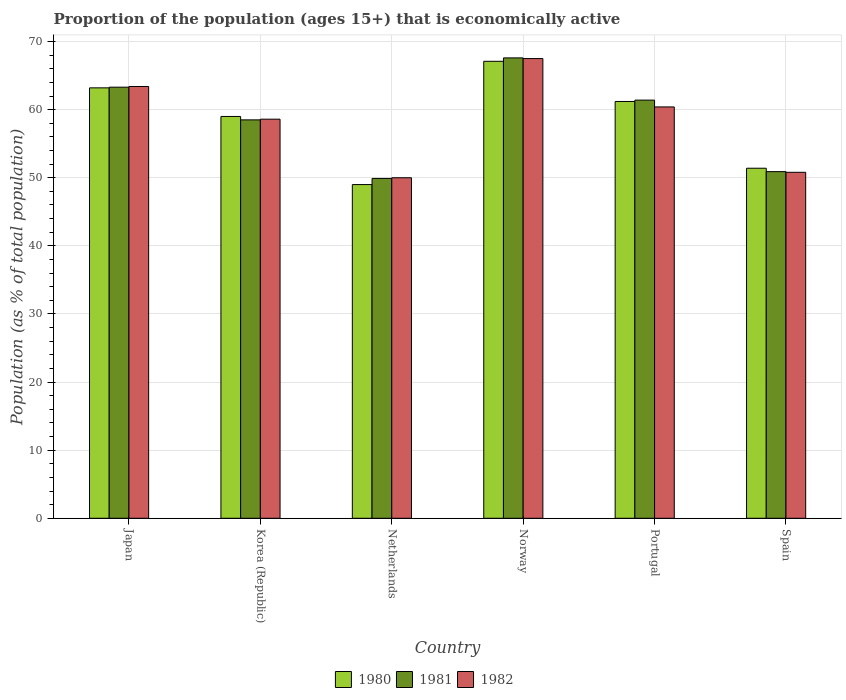How many groups of bars are there?
Your response must be concise. 6. Are the number of bars per tick equal to the number of legend labels?
Keep it short and to the point. Yes. Are the number of bars on each tick of the X-axis equal?
Keep it short and to the point. Yes. How many bars are there on the 5th tick from the right?
Provide a succinct answer. 3. What is the label of the 2nd group of bars from the left?
Your answer should be compact. Korea (Republic). In how many cases, is the number of bars for a given country not equal to the number of legend labels?
Make the answer very short. 0. What is the proportion of the population that is economically active in 1980 in Korea (Republic)?
Your answer should be compact. 59. Across all countries, what is the maximum proportion of the population that is economically active in 1981?
Make the answer very short. 67.6. In which country was the proportion of the population that is economically active in 1980 minimum?
Your response must be concise. Netherlands. What is the total proportion of the population that is economically active in 1982 in the graph?
Give a very brief answer. 350.7. What is the difference between the proportion of the population that is economically active in 1980 in Japan and that in Netherlands?
Give a very brief answer. 14.2. What is the difference between the proportion of the population that is economically active in 1981 in Norway and the proportion of the population that is economically active in 1980 in Korea (Republic)?
Your answer should be compact. 8.6. What is the average proportion of the population that is economically active in 1981 per country?
Your answer should be very brief. 58.6. What is the difference between the proportion of the population that is economically active of/in 1982 and proportion of the population that is economically active of/in 1980 in Korea (Republic)?
Give a very brief answer. -0.4. In how many countries, is the proportion of the population that is economically active in 1980 greater than 4 %?
Offer a terse response. 6. What is the ratio of the proportion of the population that is economically active in 1980 in Netherlands to that in Norway?
Provide a succinct answer. 0.73. Is the difference between the proportion of the population that is economically active in 1982 in Japan and Portugal greater than the difference between the proportion of the population that is economically active in 1980 in Japan and Portugal?
Offer a very short reply. Yes. What is the difference between the highest and the second highest proportion of the population that is economically active in 1981?
Offer a very short reply. 6.2. What is the difference between the highest and the lowest proportion of the population that is economically active in 1982?
Your answer should be very brief. 17.5. In how many countries, is the proportion of the population that is economically active in 1980 greater than the average proportion of the population that is economically active in 1980 taken over all countries?
Make the answer very short. 4. Is the sum of the proportion of the population that is economically active in 1982 in Korea (Republic) and Spain greater than the maximum proportion of the population that is economically active in 1981 across all countries?
Your answer should be very brief. Yes. What does the 1st bar from the left in Netherlands represents?
Your answer should be very brief. 1980. What does the 1st bar from the right in Japan represents?
Make the answer very short. 1982. Are all the bars in the graph horizontal?
Offer a terse response. No. How many countries are there in the graph?
Your response must be concise. 6. What is the difference between two consecutive major ticks on the Y-axis?
Provide a short and direct response. 10. Does the graph contain grids?
Provide a succinct answer. Yes. What is the title of the graph?
Offer a very short reply. Proportion of the population (ages 15+) that is economically active. What is the label or title of the X-axis?
Offer a terse response. Country. What is the label or title of the Y-axis?
Offer a very short reply. Population (as % of total population). What is the Population (as % of total population) in 1980 in Japan?
Provide a short and direct response. 63.2. What is the Population (as % of total population) in 1981 in Japan?
Your response must be concise. 63.3. What is the Population (as % of total population) in 1982 in Japan?
Make the answer very short. 63.4. What is the Population (as % of total population) in 1980 in Korea (Republic)?
Your answer should be very brief. 59. What is the Population (as % of total population) of 1981 in Korea (Republic)?
Offer a very short reply. 58.5. What is the Population (as % of total population) in 1982 in Korea (Republic)?
Keep it short and to the point. 58.6. What is the Population (as % of total population) in 1980 in Netherlands?
Keep it short and to the point. 49. What is the Population (as % of total population) in 1981 in Netherlands?
Your answer should be compact. 49.9. What is the Population (as % of total population) in 1980 in Norway?
Offer a very short reply. 67.1. What is the Population (as % of total population) of 1981 in Norway?
Provide a short and direct response. 67.6. What is the Population (as % of total population) of 1982 in Norway?
Make the answer very short. 67.5. What is the Population (as % of total population) in 1980 in Portugal?
Your response must be concise. 61.2. What is the Population (as % of total population) of 1981 in Portugal?
Make the answer very short. 61.4. What is the Population (as % of total population) of 1982 in Portugal?
Ensure brevity in your answer.  60.4. What is the Population (as % of total population) of 1980 in Spain?
Provide a succinct answer. 51.4. What is the Population (as % of total population) of 1981 in Spain?
Give a very brief answer. 50.9. What is the Population (as % of total population) in 1982 in Spain?
Offer a very short reply. 50.8. Across all countries, what is the maximum Population (as % of total population) of 1980?
Give a very brief answer. 67.1. Across all countries, what is the maximum Population (as % of total population) of 1981?
Offer a very short reply. 67.6. Across all countries, what is the maximum Population (as % of total population) in 1982?
Your answer should be compact. 67.5. Across all countries, what is the minimum Population (as % of total population) in 1980?
Make the answer very short. 49. Across all countries, what is the minimum Population (as % of total population) in 1981?
Offer a very short reply. 49.9. Across all countries, what is the minimum Population (as % of total population) of 1982?
Provide a short and direct response. 50. What is the total Population (as % of total population) of 1980 in the graph?
Your response must be concise. 350.9. What is the total Population (as % of total population) of 1981 in the graph?
Keep it short and to the point. 351.6. What is the total Population (as % of total population) in 1982 in the graph?
Your answer should be very brief. 350.7. What is the difference between the Population (as % of total population) in 1980 in Japan and that in Korea (Republic)?
Offer a very short reply. 4.2. What is the difference between the Population (as % of total population) of 1982 in Japan and that in Korea (Republic)?
Ensure brevity in your answer.  4.8. What is the difference between the Population (as % of total population) of 1980 in Japan and that in Netherlands?
Keep it short and to the point. 14.2. What is the difference between the Population (as % of total population) in 1981 in Japan and that in Netherlands?
Your response must be concise. 13.4. What is the difference between the Population (as % of total population) in 1982 in Japan and that in Norway?
Your response must be concise. -4.1. What is the difference between the Population (as % of total population) in 1980 in Japan and that in Spain?
Offer a terse response. 11.8. What is the difference between the Population (as % of total population) of 1981 in Japan and that in Spain?
Keep it short and to the point. 12.4. What is the difference between the Population (as % of total population) of 1982 in Japan and that in Spain?
Provide a short and direct response. 12.6. What is the difference between the Population (as % of total population) in 1980 in Korea (Republic) and that in Netherlands?
Make the answer very short. 10. What is the difference between the Population (as % of total population) in 1981 in Korea (Republic) and that in Netherlands?
Offer a very short reply. 8.6. What is the difference between the Population (as % of total population) in 1981 in Korea (Republic) and that in Norway?
Your answer should be compact. -9.1. What is the difference between the Population (as % of total population) of 1981 in Korea (Republic) and that in Portugal?
Your response must be concise. -2.9. What is the difference between the Population (as % of total population) in 1980 in Korea (Republic) and that in Spain?
Offer a very short reply. 7.6. What is the difference between the Population (as % of total population) of 1981 in Korea (Republic) and that in Spain?
Your answer should be compact. 7.6. What is the difference between the Population (as % of total population) in 1982 in Korea (Republic) and that in Spain?
Provide a succinct answer. 7.8. What is the difference between the Population (as % of total population) of 1980 in Netherlands and that in Norway?
Give a very brief answer. -18.1. What is the difference between the Population (as % of total population) in 1981 in Netherlands and that in Norway?
Give a very brief answer. -17.7. What is the difference between the Population (as % of total population) of 1982 in Netherlands and that in Norway?
Ensure brevity in your answer.  -17.5. What is the difference between the Population (as % of total population) of 1980 in Netherlands and that in Portugal?
Your answer should be very brief. -12.2. What is the difference between the Population (as % of total population) in 1980 in Netherlands and that in Spain?
Offer a terse response. -2.4. What is the difference between the Population (as % of total population) in 1982 in Netherlands and that in Spain?
Provide a succinct answer. -0.8. What is the difference between the Population (as % of total population) in 1980 in Norway and that in Portugal?
Provide a short and direct response. 5.9. What is the difference between the Population (as % of total population) in 1981 in Norway and that in Portugal?
Offer a terse response. 6.2. What is the difference between the Population (as % of total population) of 1982 in Norway and that in Portugal?
Offer a very short reply. 7.1. What is the difference between the Population (as % of total population) of 1980 in Portugal and that in Spain?
Provide a succinct answer. 9.8. What is the difference between the Population (as % of total population) of 1981 in Portugal and that in Spain?
Give a very brief answer. 10.5. What is the difference between the Population (as % of total population) of 1980 in Japan and the Population (as % of total population) of 1981 in Korea (Republic)?
Provide a short and direct response. 4.7. What is the difference between the Population (as % of total population) in 1981 in Japan and the Population (as % of total population) in 1982 in Korea (Republic)?
Give a very brief answer. 4.7. What is the difference between the Population (as % of total population) of 1980 in Japan and the Population (as % of total population) of 1981 in Netherlands?
Give a very brief answer. 13.3. What is the difference between the Population (as % of total population) of 1980 in Japan and the Population (as % of total population) of 1981 in Norway?
Your answer should be compact. -4.4. What is the difference between the Population (as % of total population) of 1980 in Japan and the Population (as % of total population) of 1982 in Norway?
Your answer should be very brief. -4.3. What is the difference between the Population (as % of total population) in 1980 in Japan and the Population (as % of total population) in 1981 in Portugal?
Provide a succinct answer. 1.8. What is the difference between the Population (as % of total population) in 1981 in Japan and the Population (as % of total population) in 1982 in Portugal?
Provide a succinct answer. 2.9. What is the difference between the Population (as % of total population) of 1980 in Japan and the Population (as % of total population) of 1982 in Spain?
Provide a succinct answer. 12.4. What is the difference between the Population (as % of total population) of 1981 in Japan and the Population (as % of total population) of 1982 in Spain?
Your answer should be very brief. 12.5. What is the difference between the Population (as % of total population) in 1980 in Korea (Republic) and the Population (as % of total population) in 1982 in Netherlands?
Offer a terse response. 9. What is the difference between the Population (as % of total population) in 1980 in Korea (Republic) and the Population (as % of total population) in 1981 in Norway?
Your answer should be very brief. -8.6. What is the difference between the Population (as % of total population) in 1980 in Korea (Republic) and the Population (as % of total population) in 1982 in Norway?
Your answer should be compact. -8.5. What is the difference between the Population (as % of total population) of 1981 in Korea (Republic) and the Population (as % of total population) of 1982 in Norway?
Offer a very short reply. -9. What is the difference between the Population (as % of total population) of 1981 in Korea (Republic) and the Population (as % of total population) of 1982 in Portugal?
Provide a succinct answer. -1.9. What is the difference between the Population (as % of total population) in 1980 in Netherlands and the Population (as % of total population) in 1981 in Norway?
Make the answer very short. -18.6. What is the difference between the Population (as % of total population) of 1980 in Netherlands and the Population (as % of total population) of 1982 in Norway?
Give a very brief answer. -18.5. What is the difference between the Population (as % of total population) in 1981 in Netherlands and the Population (as % of total population) in 1982 in Norway?
Ensure brevity in your answer.  -17.6. What is the difference between the Population (as % of total population) in 1980 in Netherlands and the Population (as % of total population) in 1982 in Portugal?
Make the answer very short. -11.4. What is the difference between the Population (as % of total population) in 1980 in Netherlands and the Population (as % of total population) in 1982 in Spain?
Your response must be concise. -1.8. What is the difference between the Population (as % of total population) of 1981 in Netherlands and the Population (as % of total population) of 1982 in Spain?
Ensure brevity in your answer.  -0.9. What is the difference between the Population (as % of total population) in 1981 in Norway and the Population (as % of total population) in 1982 in Portugal?
Your answer should be very brief. 7.2. What is the difference between the Population (as % of total population) in 1980 in Norway and the Population (as % of total population) in 1981 in Spain?
Offer a very short reply. 16.2. What is the difference between the Population (as % of total population) in 1981 in Norway and the Population (as % of total population) in 1982 in Spain?
Give a very brief answer. 16.8. What is the average Population (as % of total population) of 1980 per country?
Ensure brevity in your answer.  58.48. What is the average Population (as % of total population) in 1981 per country?
Your answer should be very brief. 58.6. What is the average Population (as % of total population) of 1982 per country?
Offer a very short reply. 58.45. What is the difference between the Population (as % of total population) in 1980 and Population (as % of total population) in 1982 in Japan?
Give a very brief answer. -0.2. What is the difference between the Population (as % of total population) of 1981 and Population (as % of total population) of 1982 in Japan?
Ensure brevity in your answer.  -0.1. What is the difference between the Population (as % of total population) of 1980 and Population (as % of total population) of 1981 in Korea (Republic)?
Offer a very short reply. 0.5. What is the difference between the Population (as % of total population) of 1980 and Population (as % of total population) of 1982 in Korea (Republic)?
Your answer should be compact. 0.4. What is the difference between the Population (as % of total population) in 1980 and Population (as % of total population) in 1981 in Netherlands?
Keep it short and to the point. -0.9. What is the difference between the Population (as % of total population) of 1980 and Population (as % of total population) of 1982 in Netherlands?
Provide a succinct answer. -1. What is the difference between the Population (as % of total population) in 1981 and Population (as % of total population) in 1982 in Netherlands?
Make the answer very short. -0.1. What is the difference between the Population (as % of total population) of 1980 and Population (as % of total population) of 1981 in Norway?
Provide a short and direct response. -0.5. What is the difference between the Population (as % of total population) of 1980 and Population (as % of total population) of 1982 in Norway?
Your answer should be compact. -0.4. What is the difference between the Population (as % of total population) in 1981 and Population (as % of total population) in 1982 in Norway?
Keep it short and to the point. 0.1. What is the difference between the Population (as % of total population) in 1980 and Population (as % of total population) in 1982 in Spain?
Ensure brevity in your answer.  0.6. What is the difference between the Population (as % of total population) in 1981 and Population (as % of total population) in 1982 in Spain?
Your answer should be very brief. 0.1. What is the ratio of the Population (as % of total population) of 1980 in Japan to that in Korea (Republic)?
Offer a terse response. 1.07. What is the ratio of the Population (as % of total population) of 1981 in Japan to that in Korea (Republic)?
Offer a terse response. 1.08. What is the ratio of the Population (as % of total population) of 1982 in Japan to that in Korea (Republic)?
Offer a very short reply. 1.08. What is the ratio of the Population (as % of total population) of 1980 in Japan to that in Netherlands?
Provide a succinct answer. 1.29. What is the ratio of the Population (as % of total population) of 1981 in Japan to that in Netherlands?
Offer a very short reply. 1.27. What is the ratio of the Population (as % of total population) of 1982 in Japan to that in Netherlands?
Ensure brevity in your answer.  1.27. What is the ratio of the Population (as % of total population) in 1980 in Japan to that in Norway?
Provide a succinct answer. 0.94. What is the ratio of the Population (as % of total population) in 1981 in Japan to that in Norway?
Give a very brief answer. 0.94. What is the ratio of the Population (as % of total population) in 1982 in Japan to that in Norway?
Provide a short and direct response. 0.94. What is the ratio of the Population (as % of total population) of 1980 in Japan to that in Portugal?
Give a very brief answer. 1.03. What is the ratio of the Population (as % of total population) of 1981 in Japan to that in Portugal?
Offer a very short reply. 1.03. What is the ratio of the Population (as % of total population) of 1982 in Japan to that in Portugal?
Your answer should be very brief. 1.05. What is the ratio of the Population (as % of total population) in 1980 in Japan to that in Spain?
Give a very brief answer. 1.23. What is the ratio of the Population (as % of total population) in 1981 in Japan to that in Spain?
Provide a short and direct response. 1.24. What is the ratio of the Population (as % of total population) in 1982 in Japan to that in Spain?
Offer a terse response. 1.25. What is the ratio of the Population (as % of total population) of 1980 in Korea (Republic) to that in Netherlands?
Your answer should be compact. 1.2. What is the ratio of the Population (as % of total population) in 1981 in Korea (Republic) to that in Netherlands?
Your response must be concise. 1.17. What is the ratio of the Population (as % of total population) of 1982 in Korea (Republic) to that in Netherlands?
Your answer should be compact. 1.17. What is the ratio of the Population (as % of total population) of 1980 in Korea (Republic) to that in Norway?
Ensure brevity in your answer.  0.88. What is the ratio of the Population (as % of total population) of 1981 in Korea (Republic) to that in Norway?
Give a very brief answer. 0.87. What is the ratio of the Population (as % of total population) in 1982 in Korea (Republic) to that in Norway?
Offer a very short reply. 0.87. What is the ratio of the Population (as % of total population) in 1980 in Korea (Republic) to that in Portugal?
Keep it short and to the point. 0.96. What is the ratio of the Population (as % of total population) in 1981 in Korea (Republic) to that in Portugal?
Provide a succinct answer. 0.95. What is the ratio of the Population (as % of total population) in 1982 in Korea (Republic) to that in Portugal?
Offer a very short reply. 0.97. What is the ratio of the Population (as % of total population) in 1980 in Korea (Republic) to that in Spain?
Your answer should be very brief. 1.15. What is the ratio of the Population (as % of total population) of 1981 in Korea (Republic) to that in Spain?
Offer a very short reply. 1.15. What is the ratio of the Population (as % of total population) of 1982 in Korea (Republic) to that in Spain?
Make the answer very short. 1.15. What is the ratio of the Population (as % of total population) of 1980 in Netherlands to that in Norway?
Provide a short and direct response. 0.73. What is the ratio of the Population (as % of total population) of 1981 in Netherlands to that in Norway?
Ensure brevity in your answer.  0.74. What is the ratio of the Population (as % of total population) of 1982 in Netherlands to that in Norway?
Your answer should be compact. 0.74. What is the ratio of the Population (as % of total population) in 1980 in Netherlands to that in Portugal?
Keep it short and to the point. 0.8. What is the ratio of the Population (as % of total population) in 1981 in Netherlands to that in Portugal?
Keep it short and to the point. 0.81. What is the ratio of the Population (as % of total population) of 1982 in Netherlands to that in Portugal?
Offer a terse response. 0.83. What is the ratio of the Population (as % of total population) of 1980 in Netherlands to that in Spain?
Your answer should be compact. 0.95. What is the ratio of the Population (as % of total population) in 1981 in Netherlands to that in Spain?
Provide a short and direct response. 0.98. What is the ratio of the Population (as % of total population) of 1982 in Netherlands to that in Spain?
Provide a succinct answer. 0.98. What is the ratio of the Population (as % of total population) of 1980 in Norway to that in Portugal?
Your response must be concise. 1.1. What is the ratio of the Population (as % of total population) of 1981 in Norway to that in Portugal?
Provide a short and direct response. 1.1. What is the ratio of the Population (as % of total population) in 1982 in Norway to that in Portugal?
Ensure brevity in your answer.  1.12. What is the ratio of the Population (as % of total population) of 1980 in Norway to that in Spain?
Offer a very short reply. 1.31. What is the ratio of the Population (as % of total population) of 1981 in Norway to that in Spain?
Give a very brief answer. 1.33. What is the ratio of the Population (as % of total population) of 1982 in Norway to that in Spain?
Ensure brevity in your answer.  1.33. What is the ratio of the Population (as % of total population) in 1980 in Portugal to that in Spain?
Your response must be concise. 1.19. What is the ratio of the Population (as % of total population) in 1981 in Portugal to that in Spain?
Ensure brevity in your answer.  1.21. What is the ratio of the Population (as % of total population) in 1982 in Portugal to that in Spain?
Provide a succinct answer. 1.19. What is the difference between the highest and the second highest Population (as % of total population) of 1980?
Ensure brevity in your answer.  3.9. What is the difference between the highest and the lowest Population (as % of total population) of 1980?
Provide a short and direct response. 18.1. What is the difference between the highest and the lowest Population (as % of total population) of 1981?
Keep it short and to the point. 17.7. 